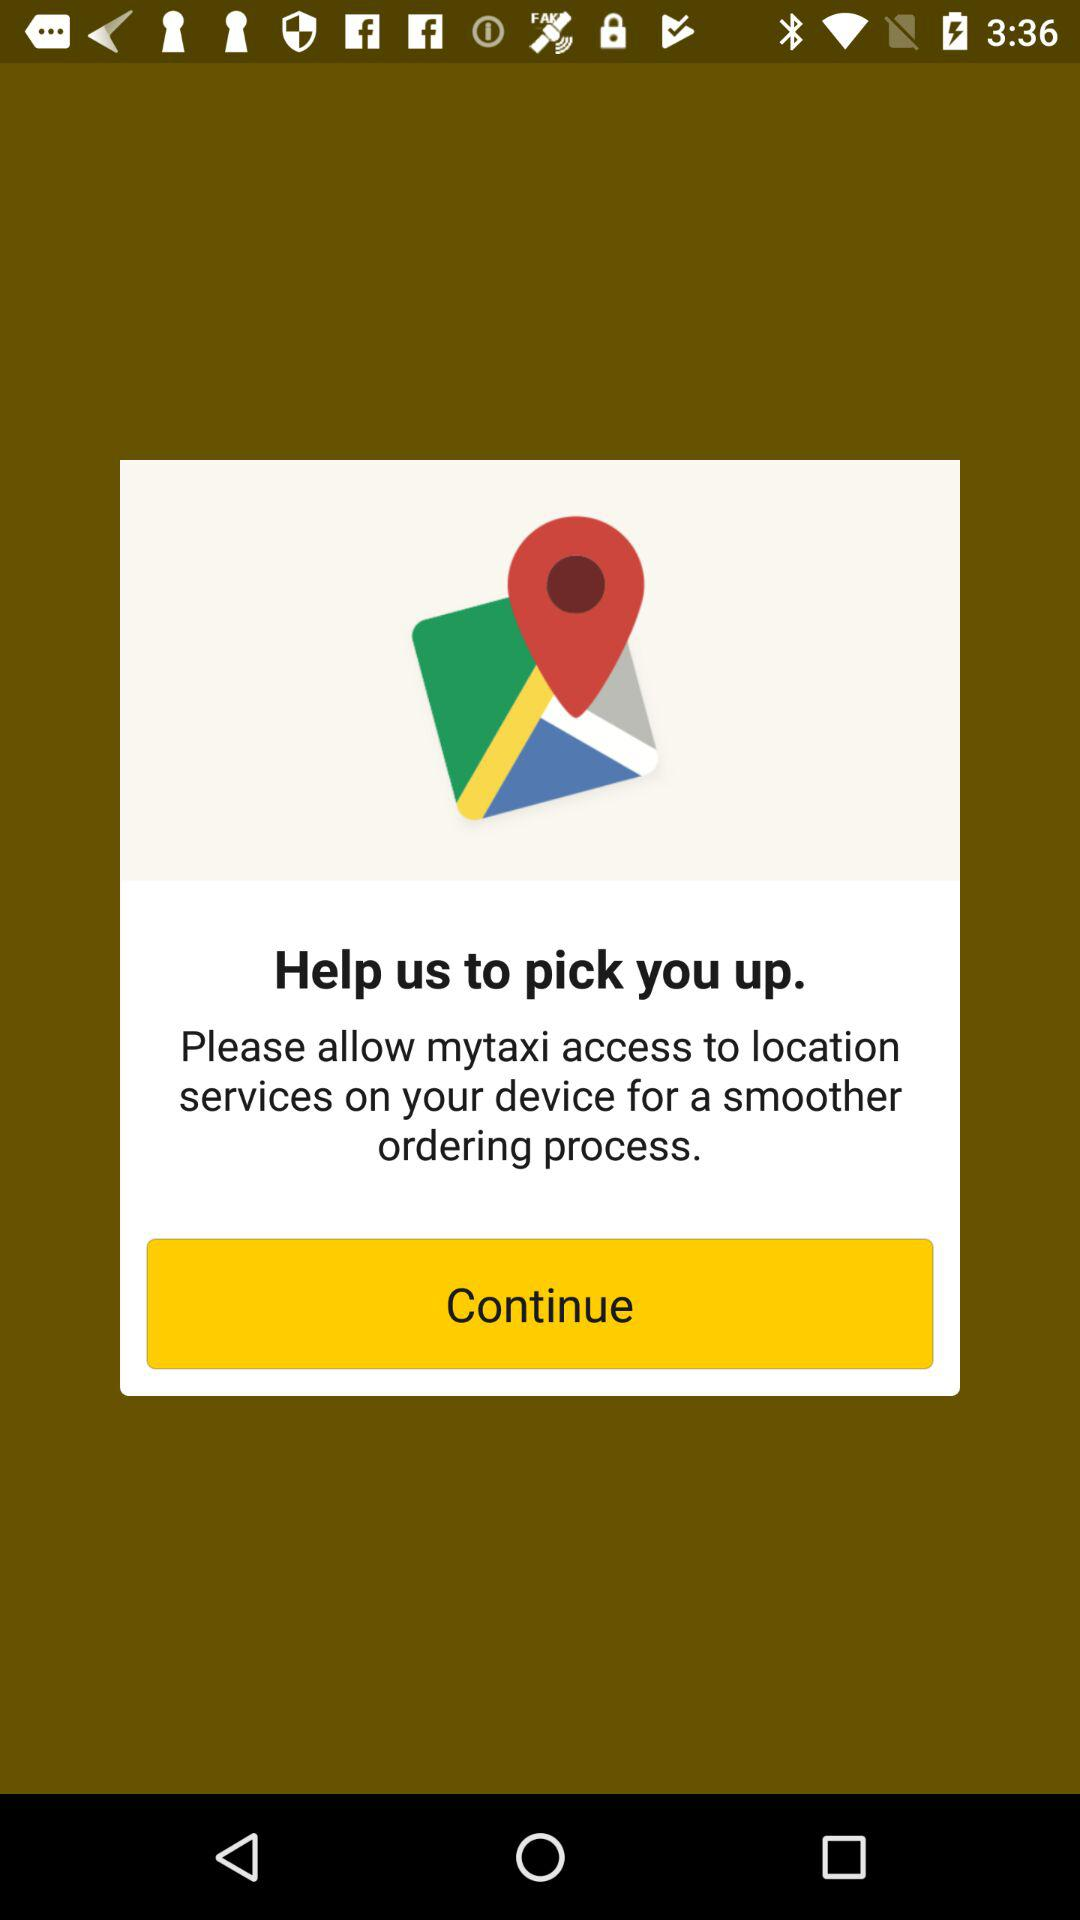What application is asking for permission? The application that is asking for permission is "mytaxi". 